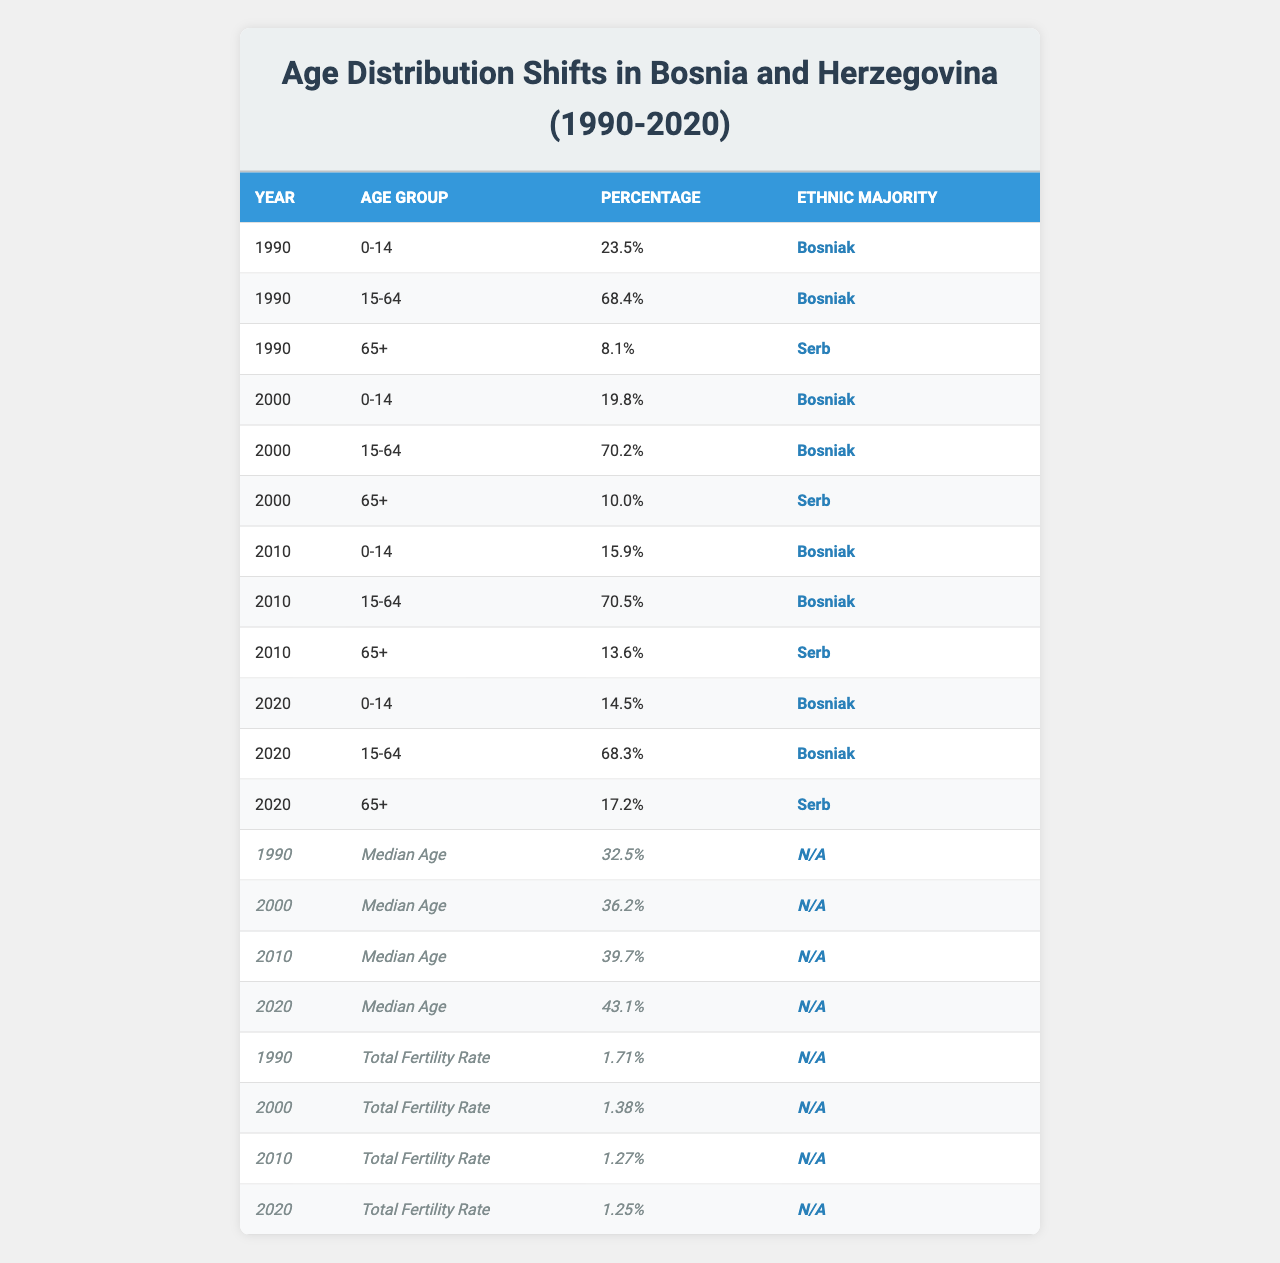What was the percentage of the population in the age group 0-14 in 1990? The table shows that in 1990, the percentage of the population in the age group 0-14 was 23.5%.
Answer: 23.5% What is the median age in 2020? According to the table, the median age in 2020 was 43.1 years.
Answer: 43.1 How did the percentage of the 15-64 age group change from 1990 to 2020? In 1990, it was 68.4%, and in 2020, it was 68.3%. The change is a decrease of 0.1%.
Answer: Decreased by 0.1% What was the total fertility rate in 2000? The table indicates that the total fertility rate in 2000 was 1.38.
Answer: 1.38 Which age group saw the highest percentage increase from 2000 to 2010? The age group 65+ increased from 10.0% in 2000 to 13.6% in 2010, which is an increase of 3.6%.
Answer: 65+ In what year did the percentage of the 0-14 age group reach its lowest value? The lowest percentage of the 0-14 age group was in 2010 at 15.9%.
Answer: 2010 What can be inferred about the population's aging trend based on the median age from 1990 to 2020? The median age increased from 32.5 years in 1990 to 43.1 years in 2020, indicating an aging population over the 30-year period.
Answer: The population is aging Did the percentage of the ethnic majority among the age groups change significantly from 1990 to 2020? Yes, the ethnic majority remained Bosniak for age groups 0-14 and 15-64, but for 65+, the percentage increased from 8.1% in 1990 to 17.2% in 2020 for Serbs, indicating a shift in population composition.
Answer: Yes What is the total percentage of the population in the age group 65+ for 2010 and 2020 combined? For 2010, the percentage is 13.6%, and for 2020, it is 17.2%. The total is 13.6% + 17.2% = 30.8%.
Answer: 30.8% How did the fertility rate change from 1990 to 2020? The total fertility rate decreased from 1.71 in 1990 to 1.25 in 2020, indicating a decline in fertility.
Answer: Decreased by 0.46 